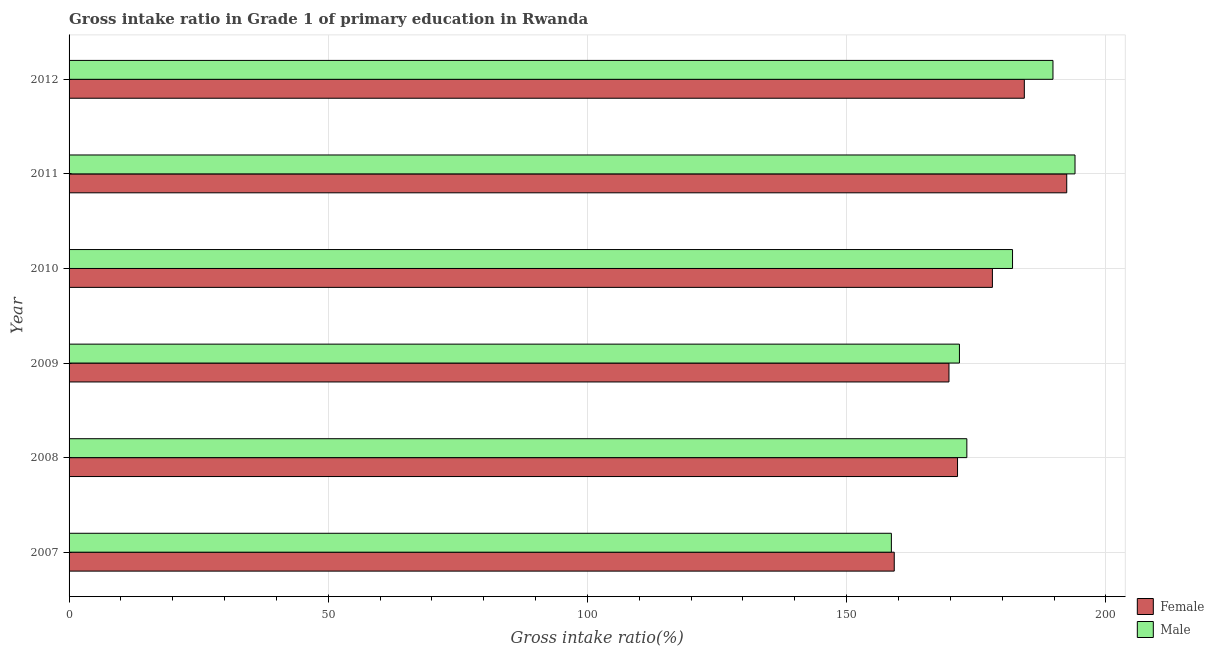How many different coloured bars are there?
Make the answer very short. 2. How many groups of bars are there?
Your answer should be very brief. 6. Are the number of bars per tick equal to the number of legend labels?
Make the answer very short. Yes. What is the gross intake ratio(male) in 2011?
Make the answer very short. 194.05. Across all years, what is the maximum gross intake ratio(male)?
Your answer should be compact. 194.05. Across all years, what is the minimum gross intake ratio(male)?
Make the answer very short. 158.63. In which year was the gross intake ratio(female) maximum?
Offer a terse response. 2011. In which year was the gross intake ratio(female) minimum?
Your response must be concise. 2007. What is the total gross intake ratio(male) in the graph?
Ensure brevity in your answer.  1069.42. What is the difference between the gross intake ratio(female) in 2008 and that in 2010?
Ensure brevity in your answer.  -6.73. What is the difference between the gross intake ratio(female) in 2008 and the gross intake ratio(male) in 2007?
Offer a very short reply. 12.76. What is the average gross intake ratio(male) per year?
Offer a very short reply. 178.24. In the year 2009, what is the difference between the gross intake ratio(female) and gross intake ratio(male)?
Your answer should be compact. -2.02. What is the ratio of the gross intake ratio(female) in 2009 to that in 2012?
Your answer should be compact. 0.92. Is the gross intake ratio(male) in 2010 less than that in 2012?
Your answer should be compact. Yes. What is the difference between the highest and the second highest gross intake ratio(male)?
Give a very brief answer. 4.25. What is the difference between the highest and the lowest gross intake ratio(female)?
Your response must be concise. 33.27. What does the 1st bar from the bottom in 2008 represents?
Give a very brief answer. Female. How many bars are there?
Your response must be concise. 12. How many years are there in the graph?
Keep it short and to the point. 6. Does the graph contain any zero values?
Your answer should be compact. No. Does the graph contain grids?
Offer a terse response. Yes. How many legend labels are there?
Make the answer very short. 2. What is the title of the graph?
Provide a succinct answer. Gross intake ratio in Grade 1 of primary education in Rwanda. Does "Registered firms" appear as one of the legend labels in the graph?
Offer a terse response. No. What is the label or title of the X-axis?
Your response must be concise. Gross intake ratio(%). What is the label or title of the Y-axis?
Your answer should be very brief. Year. What is the Gross intake ratio(%) of Female in 2007?
Provide a short and direct response. 159.18. What is the Gross intake ratio(%) in Male in 2007?
Make the answer very short. 158.63. What is the Gross intake ratio(%) in Female in 2008?
Offer a terse response. 171.39. What is the Gross intake ratio(%) in Male in 2008?
Make the answer very short. 173.19. What is the Gross intake ratio(%) in Female in 2009?
Make the answer very short. 169.74. What is the Gross intake ratio(%) of Male in 2009?
Keep it short and to the point. 171.76. What is the Gross intake ratio(%) in Female in 2010?
Ensure brevity in your answer.  178.12. What is the Gross intake ratio(%) of Male in 2010?
Give a very brief answer. 182. What is the Gross intake ratio(%) in Female in 2011?
Offer a very short reply. 192.45. What is the Gross intake ratio(%) of Male in 2011?
Provide a succinct answer. 194.05. What is the Gross intake ratio(%) of Female in 2012?
Your answer should be compact. 184.28. What is the Gross intake ratio(%) in Male in 2012?
Offer a terse response. 189.8. Across all years, what is the maximum Gross intake ratio(%) of Female?
Offer a very short reply. 192.45. Across all years, what is the maximum Gross intake ratio(%) in Male?
Provide a short and direct response. 194.05. Across all years, what is the minimum Gross intake ratio(%) in Female?
Offer a terse response. 159.18. Across all years, what is the minimum Gross intake ratio(%) in Male?
Make the answer very short. 158.63. What is the total Gross intake ratio(%) of Female in the graph?
Provide a short and direct response. 1055.16. What is the total Gross intake ratio(%) of Male in the graph?
Your answer should be very brief. 1069.42. What is the difference between the Gross intake ratio(%) of Female in 2007 and that in 2008?
Give a very brief answer. -12.21. What is the difference between the Gross intake ratio(%) in Male in 2007 and that in 2008?
Provide a short and direct response. -14.56. What is the difference between the Gross intake ratio(%) of Female in 2007 and that in 2009?
Your answer should be very brief. -10.56. What is the difference between the Gross intake ratio(%) in Male in 2007 and that in 2009?
Offer a terse response. -13.13. What is the difference between the Gross intake ratio(%) in Female in 2007 and that in 2010?
Keep it short and to the point. -18.93. What is the difference between the Gross intake ratio(%) in Male in 2007 and that in 2010?
Give a very brief answer. -23.37. What is the difference between the Gross intake ratio(%) of Female in 2007 and that in 2011?
Your answer should be very brief. -33.27. What is the difference between the Gross intake ratio(%) in Male in 2007 and that in 2011?
Your answer should be very brief. -35.42. What is the difference between the Gross intake ratio(%) in Female in 2007 and that in 2012?
Provide a succinct answer. -25.09. What is the difference between the Gross intake ratio(%) in Male in 2007 and that in 2012?
Your answer should be compact. -31.17. What is the difference between the Gross intake ratio(%) in Female in 2008 and that in 2009?
Give a very brief answer. 1.65. What is the difference between the Gross intake ratio(%) of Male in 2008 and that in 2009?
Give a very brief answer. 1.43. What is the difference between the Gross intake ratio(%) of Female in 2008 and that in 2010?
Provide a succinct answer. -6.73. What is the difference between the Gross intake ratio(%) of Male in 2008 and that in 2010?
Offer a very short reply. -8.81. What is the difference between the Gross intake ratio(%) of Female in 2008 and that in 2011?
Offer a terse response. -21.07. What is the difference between the Gross intake ratio(%) of Male in 2008 and that in 2011?
Ensure brevity in your answer.  -20.86. What is the difference between the Gross intake ratio(%) of Female in 2008 and that in 2012?
Your answer should be compact. -12.89. What is the difference between the Gross intake ratio(%) in Male in 2008 and that in 2012?
Keep it short and to the point. -16.61. What is the difference between the Gross intake ratio(%) of Female in 2009 and that in 2010?
Your response must be concise. -8.38. What is the difference between the Gross intake ratio(%) of Male in 2009 and that in 2010?
Keep it short and to the point. -10.24. What is the difference between the Gross intake ratio(%) of Female in 2009 and that in 2011?
Your answer should be compact. -22.72. What is the difference between the Gross intake ratio(%) of Male in 2009 and that in 2011?
Provide a short and direct response. -22.29. What is the difference between the Gross intake ratio(%) in Female in 2009 and that in 2012?
Offer a terse response. -14.54. What is the difference between the Gross intake ratio(%) of Male in 2009 and that in 2012?
Ensure brevity in your answer.  -18.04. What is the difference between the Gross intake ratio(%) in Female in 2010 and that in 2011?
Give a very brief answer. -14.34. What is the difference between the Gross intake ratio(%) in Male in 2010 and that in 2011?
Ensure brevity in your answer.  -12.05. What is the difference between the Gross intake ratio(%) in Female in 2010 and that in 2012?
Offer a terse response. -6.16. What is the difference between the Gross intake ratio(%) in Male in 2010 and that in 2012?
Keep it short and to the point. -7.8. What is the difference between the Gross intake ratio(%) in Female in 2011 and that in 2012?
Offer a very short reply. 8.18. What is the difference between the Gross intake ratio(%) in Male in 2011 and that in 2012?
Provide a short and direct response. 4.25. What is the difference between the Gross intake ratio(%) in Female in 2007 and the Gross intake ratio(%) in Male in 2008?
Ensure brevity in your answer.  -14. What is the difference between the Gross intake ratio(%) in Female in 2007 and the Gross intake ratio(%) in Male in 2009?
Provide a short and direct response. -12.57. What is the difference between the Gross intake ratio(%) of Female in 2007 and the Gross intake ratio(%) of Male in 2010?
Keep it short and to the point. -22.82. What is the difference between the Gross intake ratio(%) in Female in 2007 and the Gross intake ratio(%) in Male in 2011?
Your answer should be very brief. -34.87. What is the difference between the Gross intake ratio(%) of Female in 2007 and the Gross intake ratio(%) of Male in 2012?
Your answer should be compact. -30.62. What is the difference between the Gross intake ratio(%) in Female in 2008 and the Gross intake ratio(%) in Male in 2009?
Make the answer very short. -0.37. What is the difference between the Gross intake ratio(%) in Female in 2008 and the Gross intake ratio(%) in Male in 2010?
Your answer should be compact. -10.61. What is the difference between the Gross intake ratio(%) in Female in 2008 and the Gross intake ratio(%) in Male in 2011?
Keep it short and to the point. -22.66. What is the difference between the Gross intake ratio(%) in Female in 2008 and the Gross intake ratio(%) in Male in 2012?
Offer a very short reply. -18.41. What is the difference between the Gross intake ratio(%) in Female in 2009 and the Gross intake ratio(%) in Male in 2010?
Give a very brief answer. -12.26. What is the difference between the Gross intake ratio(%) in Female in 2009 and the Gross intake ratio(%) in Male in 2011?
Your answer should be compact. -24.31. What is the difference between the Gross intake ratio(%) of Female in 2009 and the Gross intake ratio(%) of Male in 2012?
Keep it short and to the point. -20.06. What is the difference between the Gross intake ratio(%) of Female in 2010 and the Gross intake ratio(%) of Male in 2011?
Your answer should be very brief. -15.93. What is the difference between the Gross intake ratio(%) in Female in 2010 and the Gross intake ratio(%) in Male in 2012?
Keep it short and to the point. -11.68. What is the difference between the Gross intake ratio(%) of Female in 2011 and the Gross intake ratio(%) of Male in 2012?
Ensure brevity in your answer.  2.65. What is the average Gross intake ratio(%) in Female per year?
Keep it short and to the point. 175.86. What is the average Gross intake ratio(%) of Male per year?
Make the answer very short. 178.24. In the year 2007, what is the difference between the Gross intake ratio(%) of Female and Gross intake ratio(%) of Male?
Make the answer very short. 0.56. In the year 2008, what is the difference between the Gross intake ratio(%) in Female and Gross intake ratio(%) in Male?
Provide a short and direct response. -1.8. In the year 2009, what is the difference between the Gross intake ratio(%) of Female and Gross intake ratio(%) of Male?
Provide a succinct answer. -2.02. In the year 2010, what is the difference between the Gross intake ratio(%) of Female and Gross intake ratio(%) of Male?
Provide a short and direct response. -3.88. In the year 2011, what is the difference between the Gross intake ratio(%) in Female and Gross intake ratio(%) in Male?
Your response must be concise. -1.6. In the year 2012, what is the difference between the Gross intake ratio(%) in Female and Gross intake ratio(%) in Male?
Ensure brevity in your answer.  -5.52. What is the ratio of the Gross intake ratio(%) in Female in 2007 to that in 2008?
Ensure brevity in your answer.  0.93. What is the ratio of the Gross intake ratio(%) in Male in 2007 to that in 2008?
Provide a short and direct response. 0.92. What is the ratio of the Gross intake ratio(%) in Female in 2007 to that in 2009?
Offer a terse response. 0.94. What is the ratio of the Gross intake ratio(%) in Male in 2007 to that in 2009?
Provide a short and direct response. 0.92. What is the ratio of the Gross intake ratio(%) of Female in 2007 to that in 2010?
Provide a succinct answer. 0.89. What is the ratio of the Gross intake ratio(%) of Male in 2007 to that in 2010?
Keep it short and to the point. 0.87. What is the ratio of the Gross intake ratio(%) in Female in 2007 to that in 2011?
Give a very brief answer. 0.83. What is the ratio of the Gross intake ratio(%) in Male in 2007 to that in 2011?
Provide a short and direct response. 0.82. What is the ratio of the Gross intake ratio(%) in Female in 2007 to that in 2012?
Provide a short and direct response. 0.86. What is the ratio of the Gross intake ratio(%) in Male in 2007 to that in 2012?
Give a very brief answer. 0.84. What is the ratio of the Gross intake ratio(%) of Female in 2008 to that in 2009?
Offer a terse response. 1.01. What is the ratio of the Gross intake ratio(%) in Male in 2008 to that in 2009?
Ensure brevity in your answer.  1.01. What is the ratio of the Gross intake ratio(%) in Female in 2008 to that in 2010?
Give a very brief answer. 0.96. What is the ratio of the Gross intake ratio(%) in Male in 2008 to that in 2010?
Provide a short and direct response. 0.95. What is the ratio of the Gross intake ratio(%) in Female in 2008 to that in 2011?
Make the answer very short. 0.89. What is the ratio of the Gross intake ratio(%) in Male in 2008 to that in 2011?
Your answer should be very brief. 0.89. What is the ratio of the Gross intake ratio(%) of Female in 2008 to that in 2012?
Give a very brief answer. 0.93. What is the ratio of the Gross intake ratio(%) of Male in 2008 to that in 2012?
Your response must be concise. 0.91. What is the ratio of the Gross intake ratio(%) of Female in 2009 to that in 2010?
Offer a terse response. 0.95. What is the ratio of the Gross intake ratio(%) of Male in 2009 to that in 2010?
Your answer should be very brief. 0.94. What is the ratio of the Gross intake ratio(%) in Female in 2009 to that in 2011?
Keep it short and to the point. 0.88. What is the ratio of the Gross intake ratio(%) of Male in 2009 to that in 2011?
Give a very brief answer. 0.89. What is the ratio of the Gross intake ratio(%) in Female in 2009 to that in 2012?
Your response must be concise. 0.92. What is the ratio of the Gross intake ratio(%) of Male in 2009 to that in 2012?
Provide a succinct answer. 0.9. What is the ratio of the Gross intake ratio(%) of Female in 2010 to that in 2011?
Give a very brief answer. 0.93. What is the ratio of the Gross intake ratio(%) of Male in 2010 to that in 2011?
Offer a terse response. 0.94. What is the ratio of the Gross intake ratio(%) of Female in 2010 to that in 2012?
Keep it short and to the point. 0.97. What is the ratio of the Gross intake ratio(%) in Male in 2010 to that in 2012?
Your answer should be very brief. 0.96. What is the ratio of the Gross intake ratio(%) of Female in 2011 to that in 2012?
Provide a short and direct response. 1.04. What is the ratio of the Gross intake ratio(%) in Male in 2011 to that in 2012?
Offer a very short reply. 1.02. What is the difference between the highest and the second highest Gross intake ratio(%) in Female?
Make the answer very short. 8.18. What is the difference between the highest and the second highest Gross intake ratio(%) in Male?
Offer a terse response. 4.25. What is the difference between the highest and the lowest Gross intake ratio(%) of Female?
Make the answer very short. 33.27. What is the difference between the highest and the lowest Gross intake ratio(%) in Male?
Offer a terse response. 35.42. 